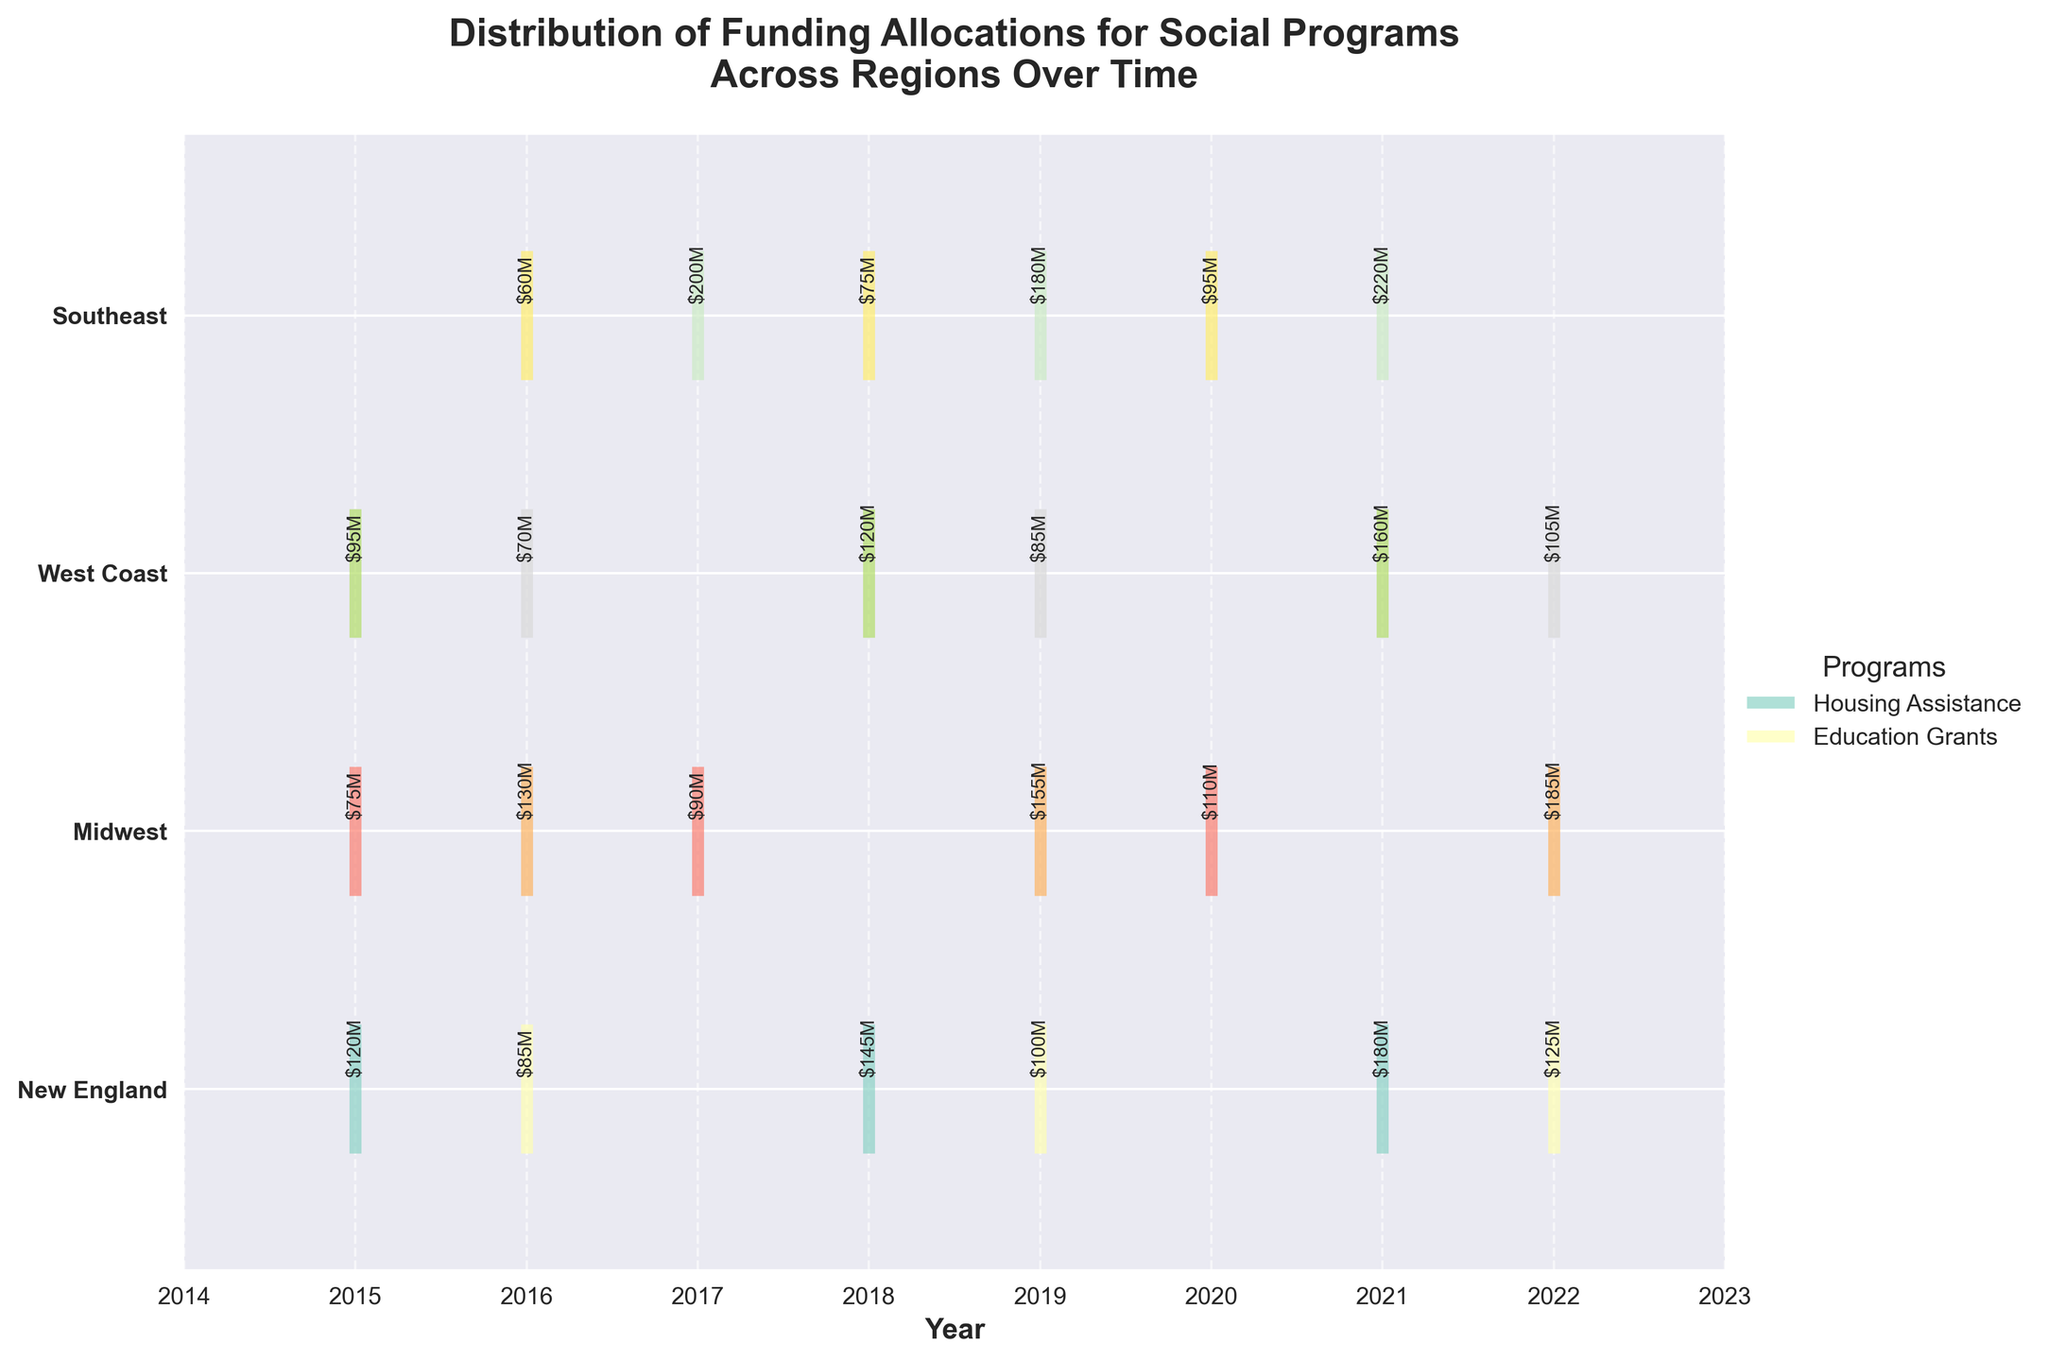What is the title of the figure? The title of the figure is prominently displayed at the top and provides an overarching summary of what the figure is about. In this case, it describes the distribution of funding allocations for social programs across regions over time.
Answer: Distribution of Funding Allocations for Social Programs Across Regions Over Time Which region received the highest funding for Healthcare Access in 2019? By looking at the event lines and annotations for 2019, we can identify Healthcare Access funding in the Midwest and observe its funding amount in millions of USD.
Answer: Midwest How many different social programs are represented in the Southeast region between 2015 and 2022? Observing the event lines for the Southeast region, we can see the vertical positions (y-ticks) and their corresponding annotations for different years. By counting distinct programs, we find the answer.
Answer: 2 What are the colors representing the Job Training program in the West Coast region? Examine the eventplot's legend to see the color coding for each program. Note the specific color assigned to the Job Training program and identify its appearance in the West Coast region.
Answer: A specific color from the Set3 colormap Which region saw the largest increase in funding for Disaster Relief from its earliest year of funding to its most recent year of funding? Identify the regions with Disaster Relief programs and compare the funding amounts between their earliest and most recent years. Calculate the difference to determine the largest increase. The Southeast region had Disaster Relief funding represented by events in different years.
Answer: Southeast How many years of funding data are displayed for the Food Security program in the Midwest region? Look at the event lines corresponding to the Food Security program in the Midwest region and count the number of distinct years represented by those lines.
Answer: 3 Compare the funding allocations for the Housing Assistance program over time in New England. Has it been increasing, decreasing, or remaining stable? Track the vertical event lines corresponding to the Housing Assistance program in New England and note the monetary values annotated above those lines. Evaluate the trend between years.
Answer: Increasing Which social program in the Southeast region received the highest funding in any given year within the dataset? Search for the annotated funding amounts in the Southeast region across all years. Identify the single highest value and its associated program.
Answer: Disaster Relief Is there any year where all regions received funding for at least one social program? Check for the presence of event lines across all regions for each individual year and ascertain if such a year exists where all regions are represented.
Answer: No In which year did the Renewable Energy program in the West Coast region receive its highest funding, and what was the amount? Locate the event lines for the Renewable Energy program in the West Coast region and compare the annotated funding amounts across different years to find the highest.
Answer: 2021, $160M 